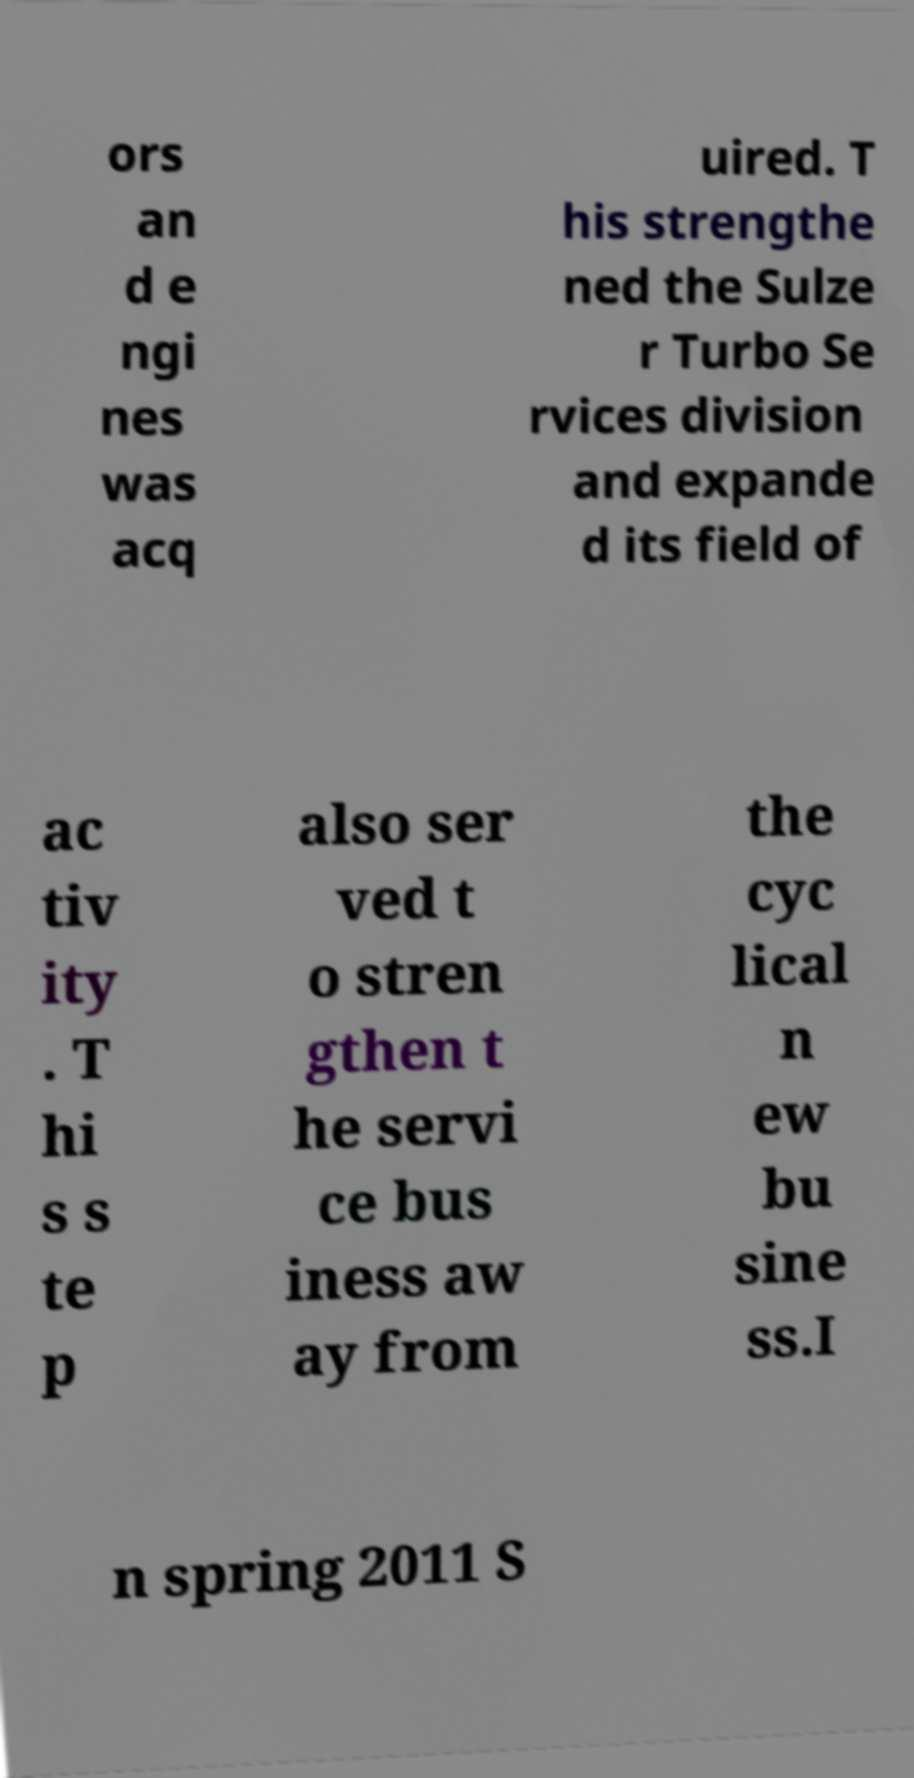Could you assist in decoding the text presented in this image and type it out clearly? ors an d e ngi nes was acq uired. T his strengthe ned the Sulze r Turbo Se rvices division and expande d its field of ac tiv ity . T hi s s te p also ser ved t o stren gthen t he servi ce bus iness aw ay from the cyc lical n ew bu sine ss.I n spring 2011 S 